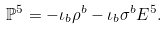Convert formula to latex. <formula><loc_0><loc_0><loc_500><loc_500>\mathbb { P } ^ { 5 } = - \iota _ { b } \rho ^ { b } - \iota _ { b } \sigma ^ { b } E ^ { 5 } .</formula> 